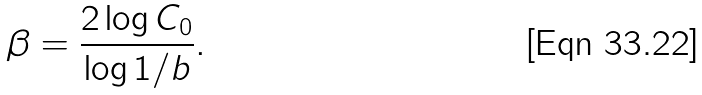<formula> <loc_0><loc_0><loc_500><loc_500>\beta = \frac { 2 \log C _ { 0 } } { \log 1 / b } .</formula> 